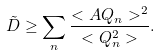<formula> <loc_0><loc_0><loc_500><loc_500>\tilde { D } \geq \sum _ { n } \frac { < A Q _ { n } > ^ { 2 } } { < Q _ { n } ^ { 2 } > } .</formula> 